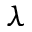<formula> <loc_0><loc_0><loc_500><loc_500>\lambda</formula> 